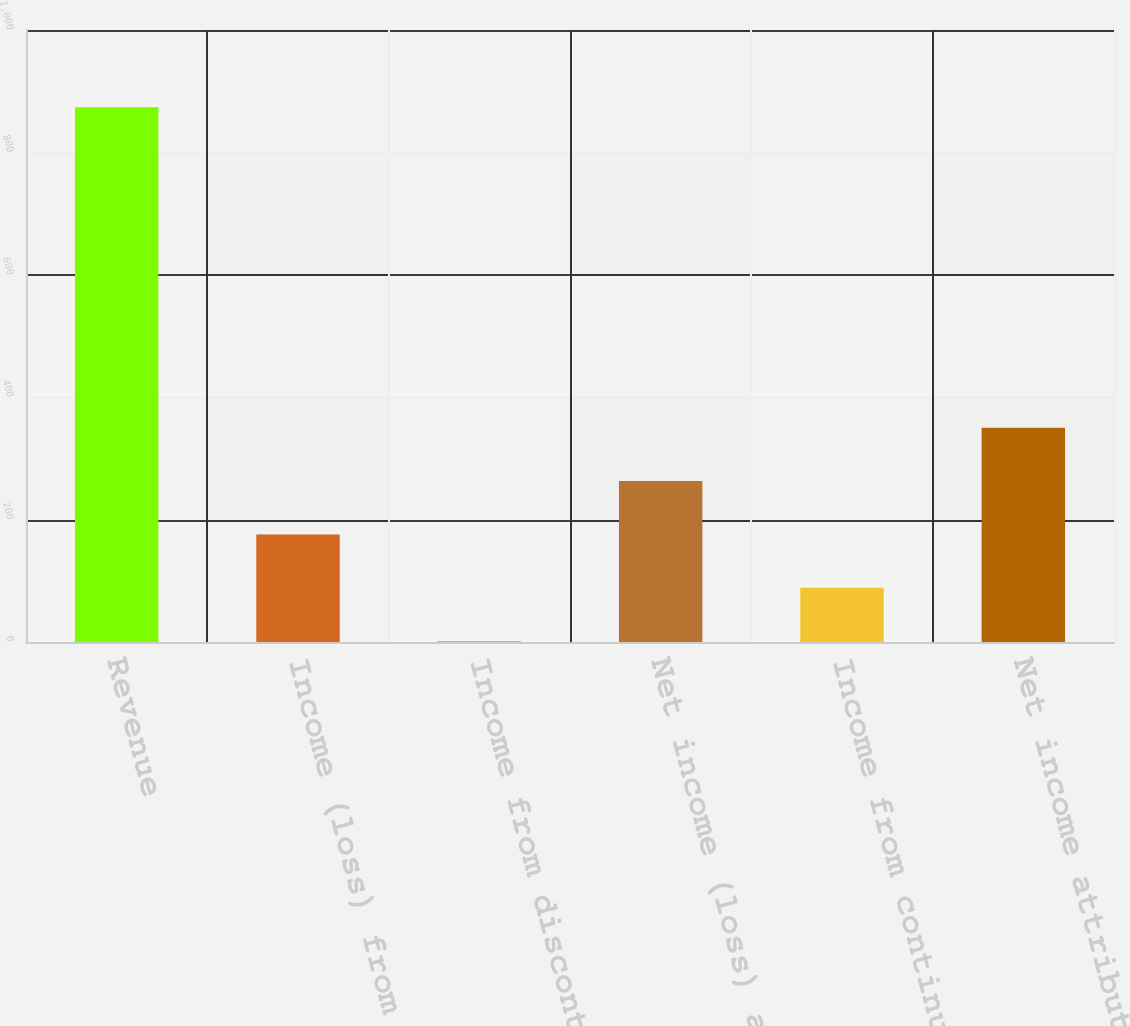Convert chart. <chart><loc_0><loc_0><loc_500><loc_500><bar_chart><fcel>Revenue<fcel>Income (loss) from continuing<fcel>Income from discontinued<fcel>Net income (loss) attributable<fcel>Income from continuing<fcel>Net income attributable to IHS<nl><fcel>873.8<fcel>175.72<fcel>1.2<fcel>262.98<fcel>88.46<fcel>350.24<nl></chart> 